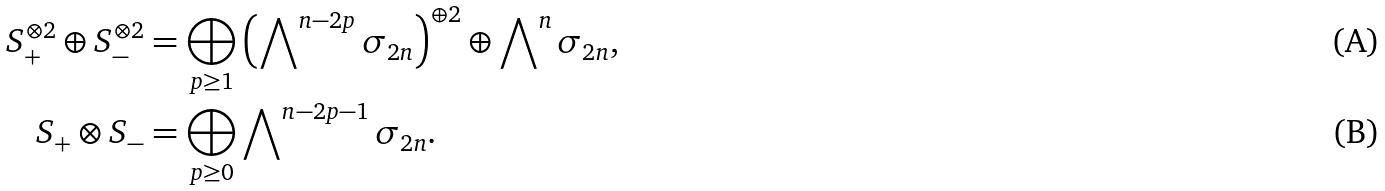<formula> <loc_0><loc_0><loc_500><loc_500>S _ { + } ^ { \otimes 2 } \oplus S _ { - } ^ { \otimes 2 } & = \bigoplus _ { p \geq 1 } \left ( \bigwedge \nolimits ^ { n - 2 p } \sigma _ { 2 n } \right ) ^ { \oplus 2 } \oplus \bigwedge \nolimits ^ { n } \sigma _ { 2 n } , \\ S _ { + } \otimes S _ { - } & = \bigoplus _ { p \geq 0 } \bigwedge \nolimits ^ { n - 2 p - 1 } \sigma _ { 2 n } .</formula> 